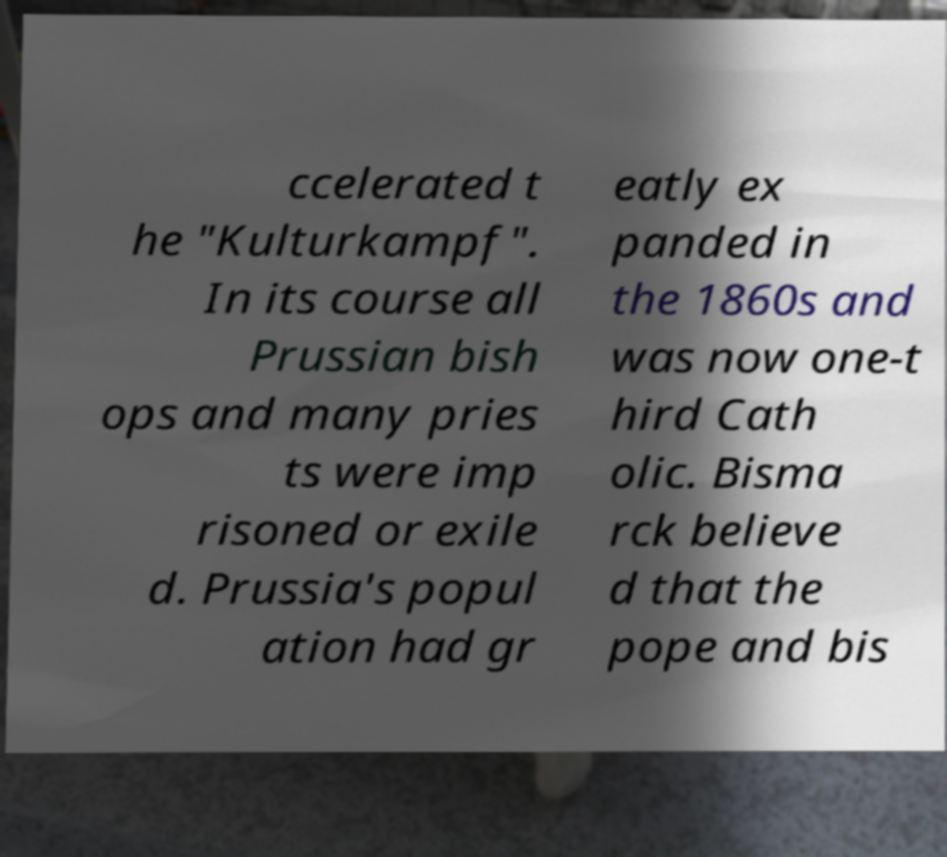Can you accurately transcribe the text from the provided image for me? ccelerated t he "Kulturkampf". In its course all Prussian bish ops and many pries ts were imp risoned or exile d. Prussia's popul ation had gr eatly ex panded in the 1860s and was now one-t hird Cath olic. Bisma rck believe d that the pope and bis 